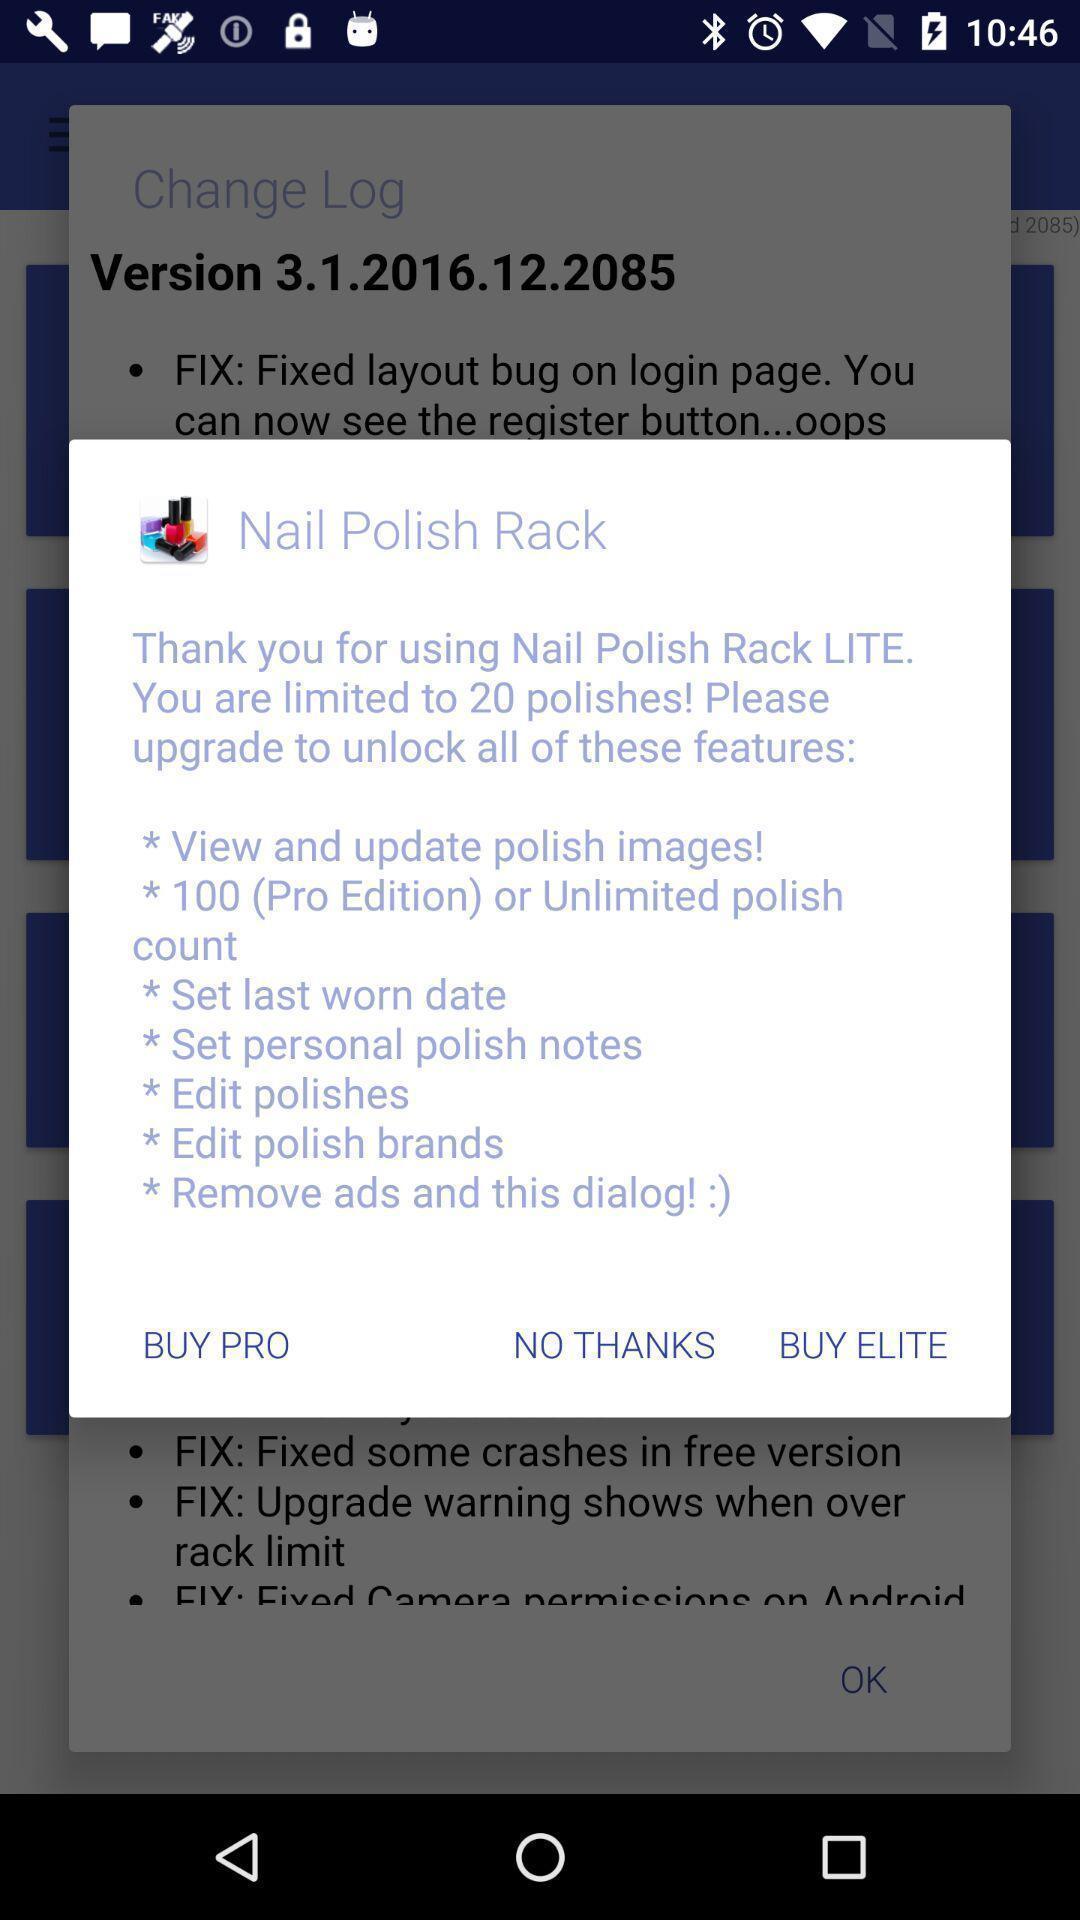Summarize the information in this screenshot. Pop-up with information about the app. 